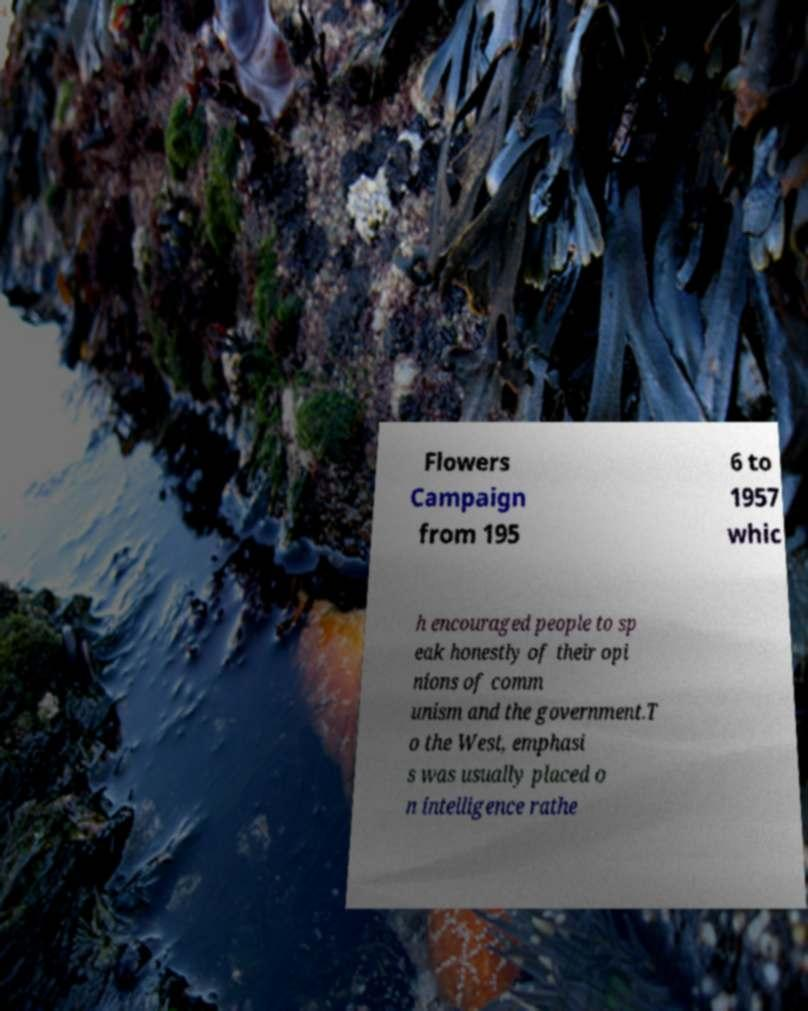Please read and relay the text visible in this image. What does it say? Flowers Campaign from 195 6 to 1957 whic h encouraged people to sp eak honestly of their opi nions of comm unism and the government.T o the West, emphasi s was usually placed o n intelligence rathe 